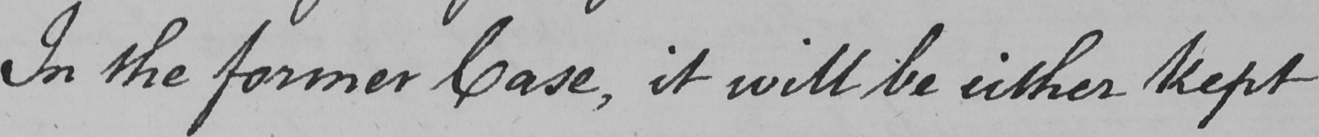Can you read and transcribe this handwriting? In the former Case , it will be either kept 